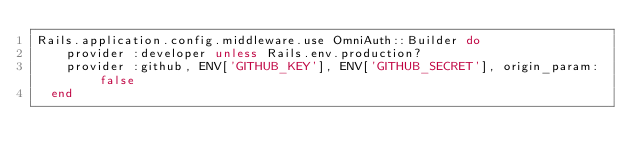<code> <loc_0><loc_0><loc_500><loc_500><_Ruby_>Rails.application.config.middleware.use OmniAuth::Builder do
    provider :developer unless Rails.env.production?
    provider :github, ENV['GITHUB_KEY'], ENV['GITHUB_SECRET'], origin_param: false
  end</code> 